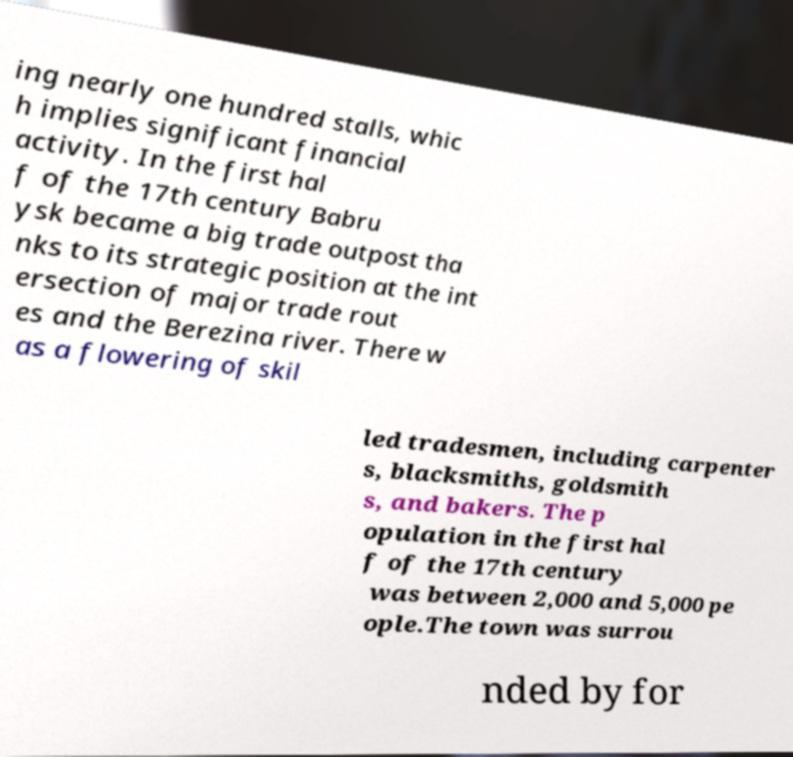Can you read and provide the text displayed in the image?This photo seems to have some interesting text. Can you extract and type it out for me? ing nearly one hundred stalls, whic h implies significant financial activity. In the first hal f of the 17th century Babru ysk became a big trade outpost tha nks to its strategic position at the int ersection of major trade rout es and the Berezina river. There w as a flowering of skil led tradesmen, including carpenter s, blacksmiths, goldsmith s, and bakers. The p opulation in the first hal f of the 17th century was between 2,000 and 5,000 pe ople.The town was surrou nded by for 